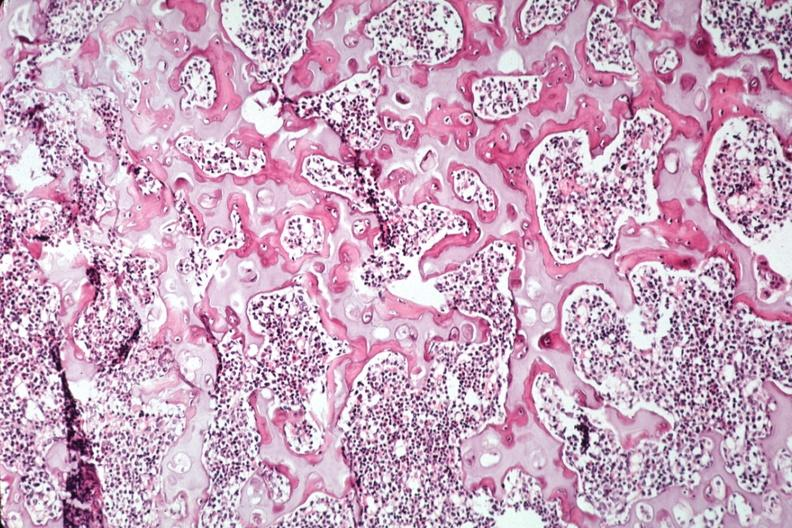does metastatic lung carcinoma show nice photo of ossifying trabecular bone?
Answer the question using a single word or phrase. No 